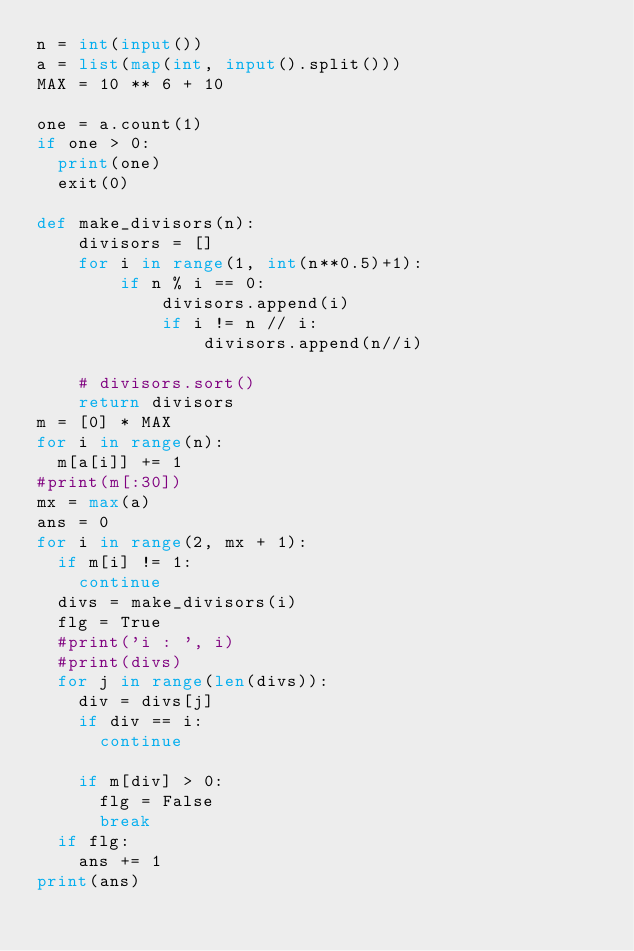<code> <loc_0><loc_0><loc_500><loc_500><_Python_>n = int(input())
a = list(map(int, input().split()))
MAX = 10 ** 6 + 10

one = a.count(1)
if one > 0:
  print(one)
  exit(0)

def make_divisors(n):
    divisors = []
    for i in range(1, int(n**0.5)+1):
        if n % i == 0:
            divisors.append(i)
            if i != n // i:
                divisors.append(n//i)

    # divisors.sort()
    return divisors
m = [0] * MAX
for i in range(n):
  m[a[i]] += 1
#print(m[:30])
mx = max(a)
ans = 0
for i in range(2, mx + 1):
  if m[i] != 1:
    continue
  divs = make_divisors(i)
  flg = True
  #print('i : ', i)
  #print(divs)
  for j in range(len(divs)):
    div = divs[j]
    if div == i:
      continue
    
    if m[div] > 0:
      flg = False
      break
  if flg:
    ans += 1
print(ans)</code> 